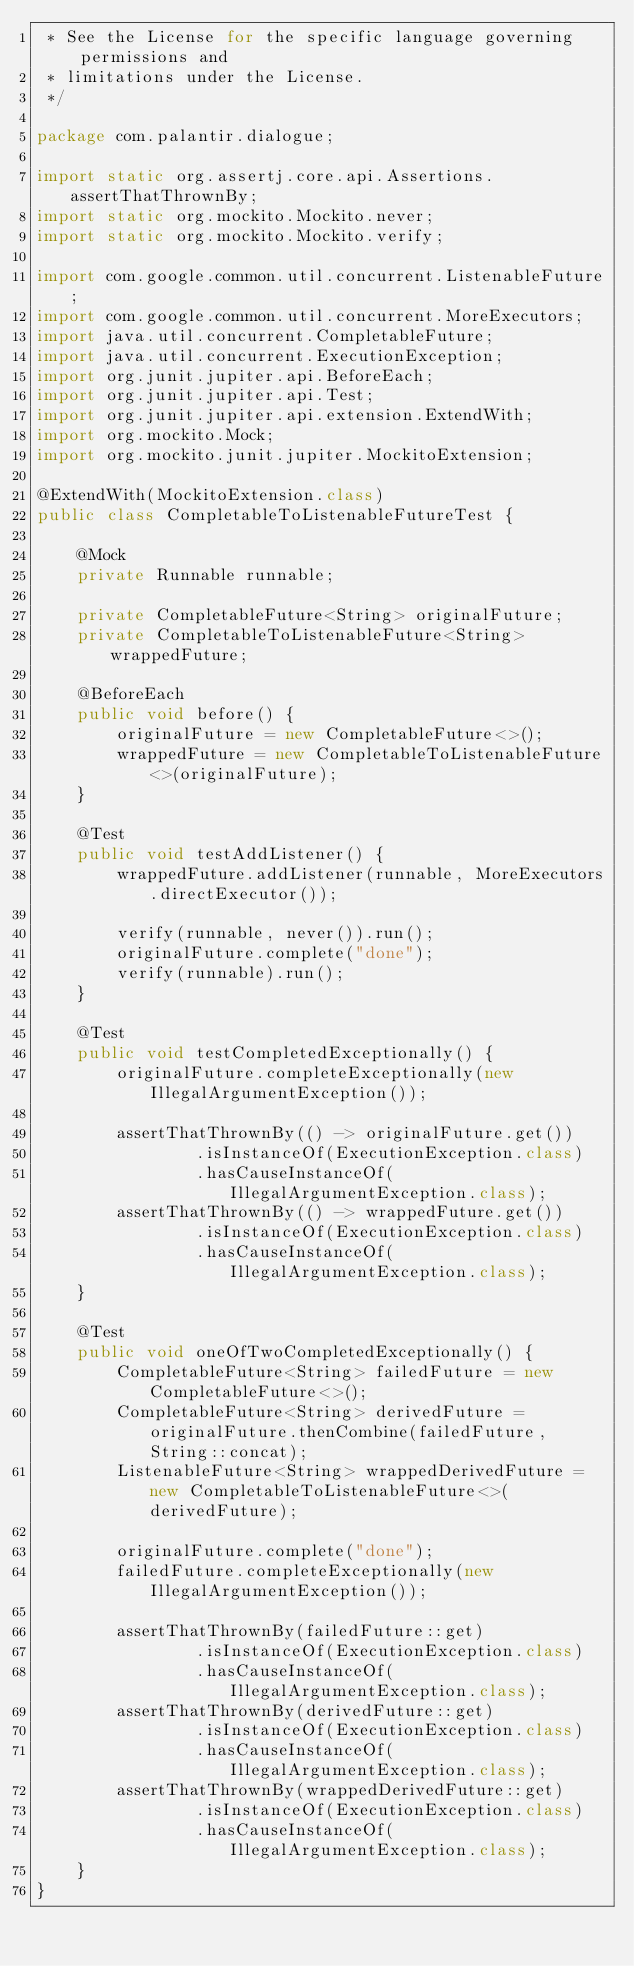Convert code to text. <code><loc_0><loc_0><loc_500><loc_500><_Java_> * See the License for the specific language governing permissions and
 * limitations under the License.
 */

package com.palantir.dialogue;

import static org.assertj.core.api.Assertions.assertThatThrownBy;
import static org.mockito.Mockito.never;
import static org.mockito.Mockito.verify;

import com.google.common.util.concurrent.ListenableFuture;
import com.google.common.util.concurrent.MoreExecutors;
import java.util.concurrent.CompletableFuture;
import java.util.concurrent.ExecutionException;
import org.junit.jupiter.api.BeforeEach;
import org.junit.jupiter.api.Test;
import org.junit.jupiter.api.extension.ExtendWith;
import org.mockito.Mock;
import org.mockito.junit.jupiter.MockitoExtension;

@ExtendWith(MockitoExtension.class)
public class CompletableToListenableFutureTest {

    @Mock
    private Runnable runnable;

    private CompletableFuture<String> originalFuture;
    private CompletableToListenableFuture<String> wrappedFuture;

    @BeforeEach
    public void before() {
        originalFuture = new CompletableFuture<>();
        wrappedFuture = new CompletableToListenableFuture<>(originalFuture);
    }

    @Test
    public void testAddListener() {
        wrappedFuture.addListener(runnable, MoreExecutors.directExecutor());

        verify(runnable, never()).run();
        originalFuture.complete("done");
        verify(runnable).run();
    }

    @Test
    public void testCompletedExceptionally() {
        originalFuture.completeExceptionally(new IllegalArgumentException());

        assertThatThrownBy(() -> originalFuture.get())
                .isInstanceOf(ExecutionException.class)
                .hasCauseInstanceOf(IllegalArgumentException.class);
        assertThatThrownBy(() -> wrappedFuture.get())
                .isInstanceOf(ExecutionException.class)
                .hasCauseInstanceOf(IllegalArgumentException.class);
    }

    @Test
    public void oneOfTwoCompletedExceptionally() {
        CompletableFuture<String> failedFuture = new CompletableFuture<>();
        CompletableFuture<String> derivedFuture = originalFuture.thenCombine(failedFuture, String::concat);
        ListenableFuture<String> wrappedDerivedFuture = new CompletableToListenableFuture<>(derivedFuture);

        originalFuture.complete("done");
        failedFuture.completeExceptionally(new IllegalArgumentException());

        assertThatThrownBy(failedFuture::get)
                .isInstanceOf(ExecutionException.class)
                .hasCauseInstanceOf(IllegalArgumentException.class);
        assertThatThrownBy(derivedFuture::get)
                .isInstanceOf(ExecutionException.class)
                .hasCauseInstanceOf(IllegalArgumentException.class);
        assertThatThrownBy(wrappedDerivedFuture::get)
                .isInstanceOf(ExecutionException.class)
                .hasCauseInstanceOf(IllegalArgumentException.class);
    }
}
</code> 